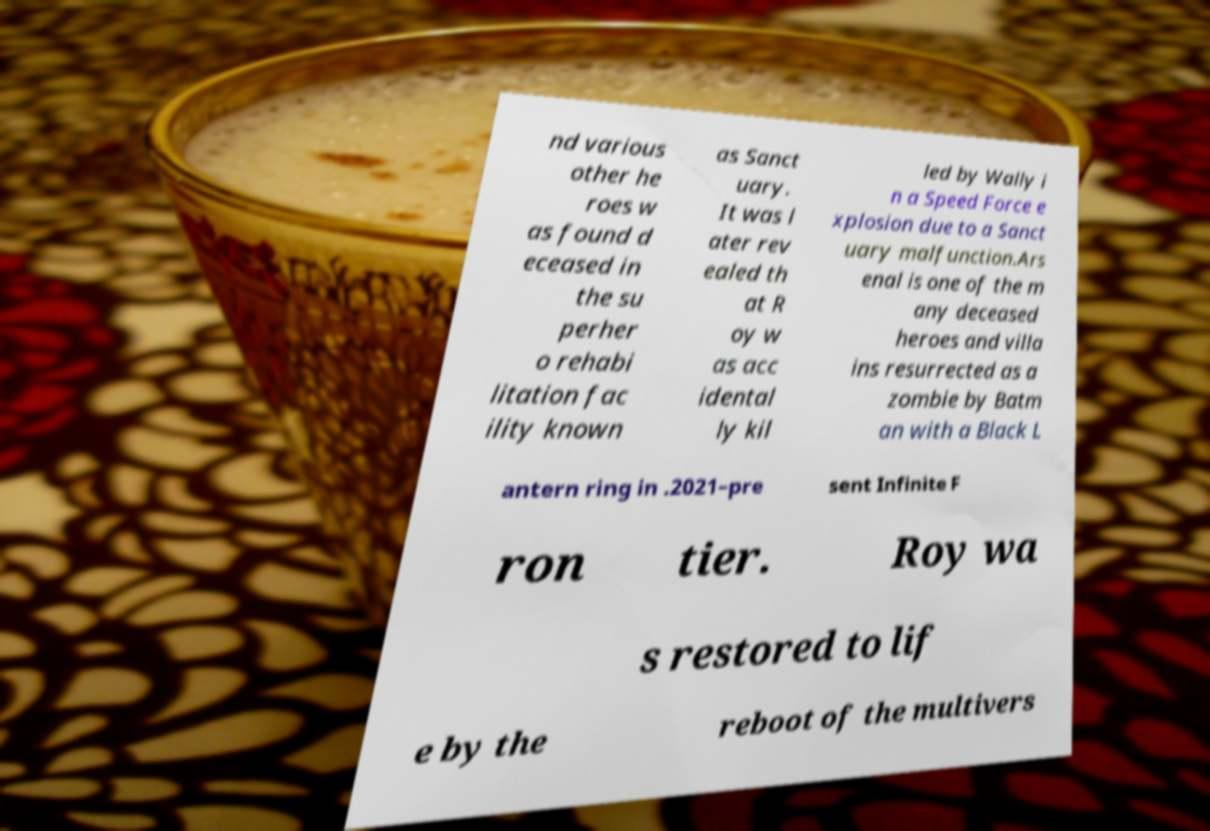Can you accurately transcribe the text from the provided image for me? nd various other he roes w as found d eceased in the su perher o rehabi litation fac ility known as Sanct uary. It was l ater rev ealed th at R oy w as acc idental ly kil led by Wally i n a Speed Force e xplosion due to a Sanct uary malfunction.Ars enal is one of the m any deceased heroes and villa ins resurrected as a zombie by Batm an with a Black L antern ring in .2021–pre sent Infinite F ron tier. Roy wa s restored to lif e by the reboot of the multivers 